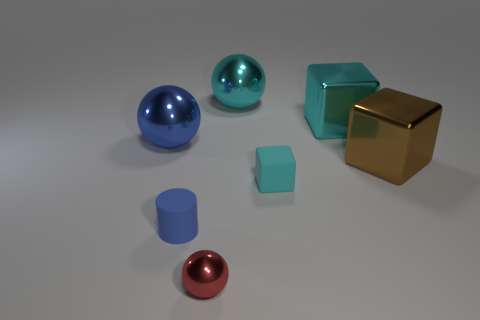Is the number of blue cylinders that are behind the blue cylinder greater than the number of cyan metallic objects that are in front of the red thing?
Keep it short and to the point. No. What is the shape of the object that is right of the cyan matte object and behind the big brown cube?
Offer a terse response. Cube. There is a small matte object right of the red metallic thing; what shape is it?
Keep it short and to the point. Cube. There is a block behind the blue sphere left of the metal cube that is to the left of the brown metallic object; how big is it?
Offer a very short reply. Large. Is the blue rubber thing the same shape as the large brown metallic object?
Your response must be concise. No. There is a cube that is on the left side of the brown metal cube and behind the tiny cyan rubber object; what size is it?
Provide a succinct answer. Large. What material is the other large thing that is the same shape as the blue metal object?
Your answer should be compact. Metal. What material is the small cylinder to the left of the brown shiny thing right of the cyan matte cube?
Provide a succinct answer. Rubber. There is a big blue metal thing; is its shape the same as the big shiny object that is behind the big cyan metallic block?
Offer a very short reply. Yes. How many shiny things are green objects or blue objects?
Provide a short and direct response. 1. 